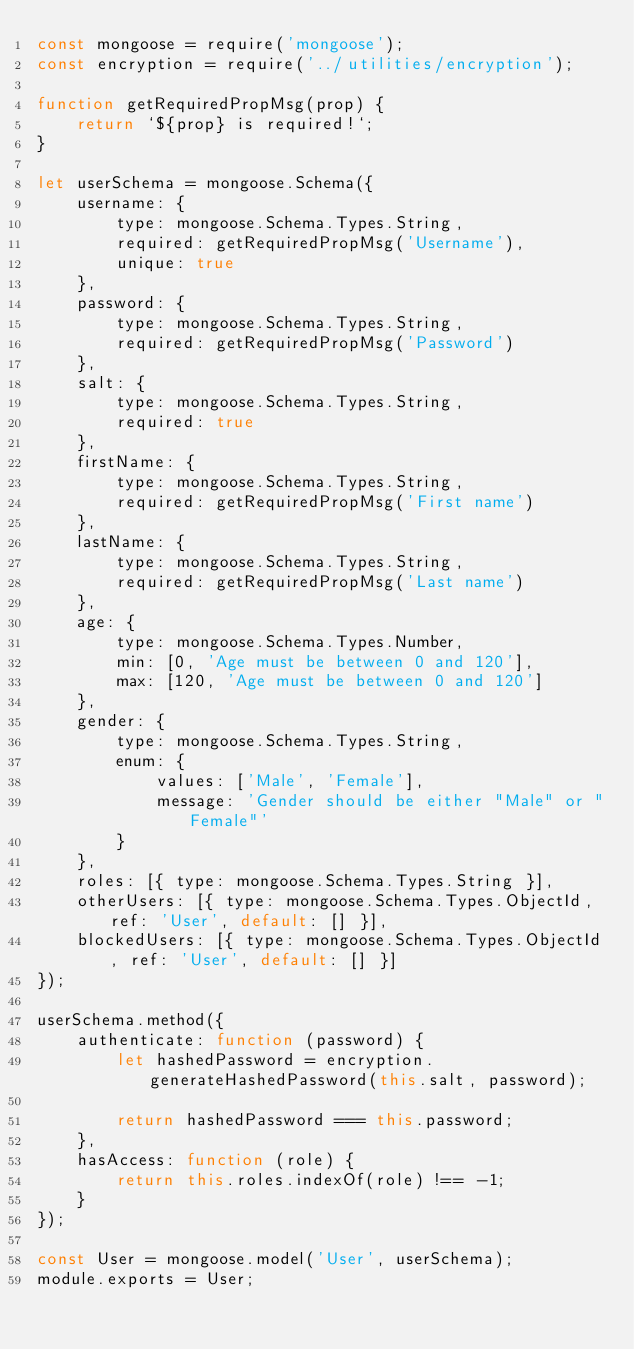<code> <loc_0><loc_0><loc_500><loc_500><_JavaScript_>const mongoose = require('mongoose');
const encryption = require('../utilities/encryption');

function getRequiredPropMsg(prop) {
    return `${prop} is required!`;
}

let userSchema = mongoose.Schema({
    username: {
        type: mongoose.Schema.Types.String,
        required: getRequiredPropMsg('Username'),
        unique: true
    },
    password: {
        type: mongoose.Schema.Types.String,
        required: getRequiredPropMsg('Password')
    },
    salt: {
        type: mongoose.Schema.Types.String,
        required: true
    },
    firstName: {
        type: mongoose.Schema.Types.String,
        required: getRequiredPropMsg('First name')
    },
    lastName: {
        type: mongoose.Schema.Types.String,
        required: getRequiredPropMsg('Last name')
    },
    age: {
        type: mongoose.Schema.Types.Number,
        min: [0, 'Age must be between 0 and 120'],
        max: [120, 'Age must be between 0 and 120']
    },
    gender: {
        type: mongoose.Schema.Types.String,
        enum: {
            values: ['Male', 'Female'],
            message: 'Gender should be either "Male" or "Female"'
        }
    },
    roles: [{ type: mongoose.Schema.Types.String }],
    otherUsers: [{ type: mongoose.Schema.Types.ObjectId, ref: 'User', default: [] }],
    blockedUsers: [{ type: mongoose.Schema.Types.ObjectId, ref: 'User', default: [] }]
});

userSchema.method({
    authenticate: function (password) {
        let hashedPassword = encryption.generateHashedPassword(this.salt, password);

        return hashedPassword === this.password;
    },
    hasAccess: function (role) {
        return this.roles.indexOf(role) !== -1;
    }
});

const User = mongoose.model('User', userSchema);
module.exports = User;
</code> 